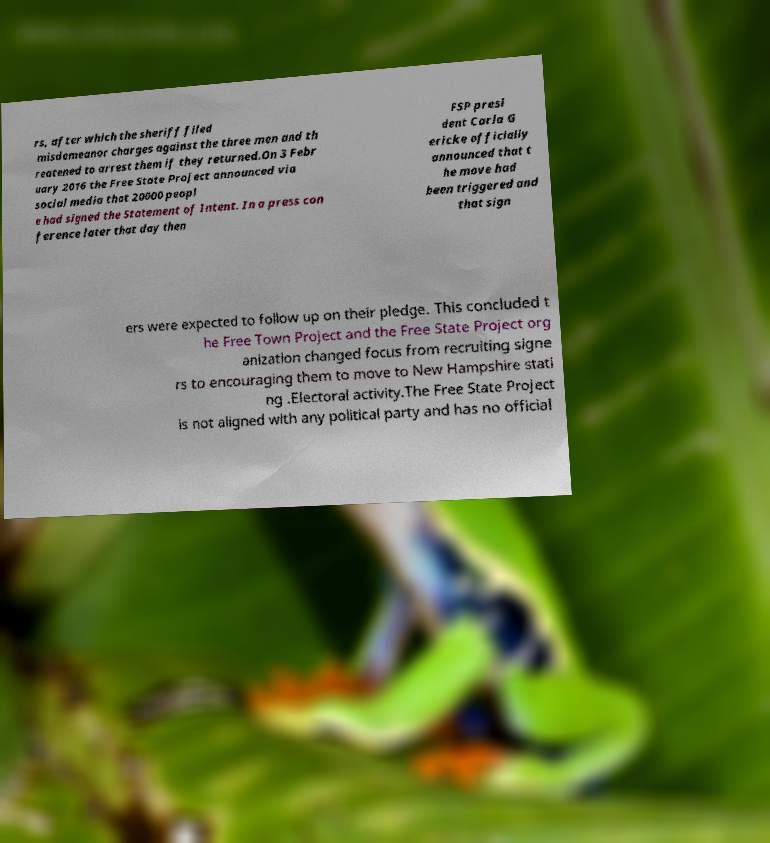Could you assist in decoding the text presented in this image and type it out clearly? rs, after which the sheriff filed misdemeanor charges against the three men and th reatened to arrest them if they returned.On 3 Febr uary 2016 the Free State Project announced via social media that 20000 peopl e had signed the Statement of Intent. In a press con ference later that day then FSP presi dent Carla G ericke officially announced that t he move had been triggered and that sign ers were expected to follow up on their pledge. This concluded t he Free Town Project and the Free State Project org anization changed focus from recruiting signe rs to encouraging them to move to New Hampshire stati ng .Electoral activity.The Free State Project is not aligned with any political party and has no official 